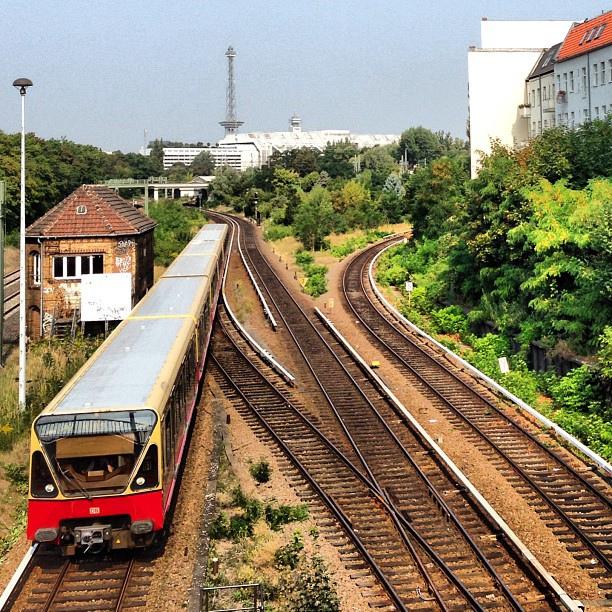What is next to the train tracks?
Concise answer only. Trees. How many trains are there?
Answer briefly. 1. What colors are on the front of the train?
Write a very short answer. Red and yellow. 